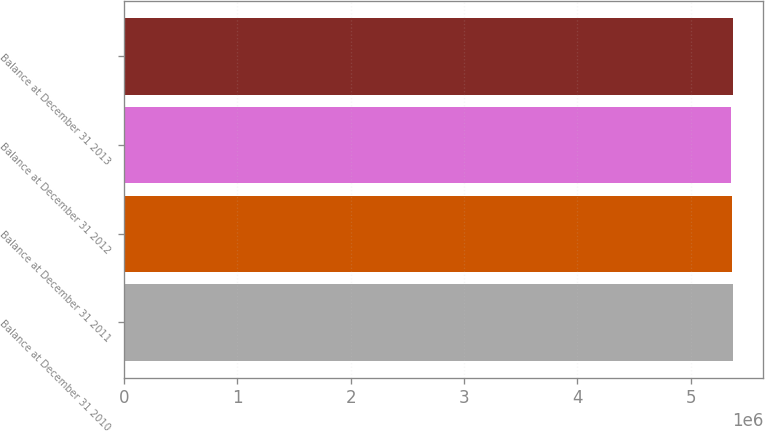Convert chart. <chart><loc_0><loc_0><loc_500><loc_500><bar_chart><fcel>Balance at December 31 2010<fcel>Balance at December 31 2011<fcel>Balance at December 31 2012<fcel>Balance at December 31 2013<nl><fcel>5.36747e+06<fcel>5.36068e+06<fcel>5.35785e+06<fcel>5.3685e+06<nl></chart> 